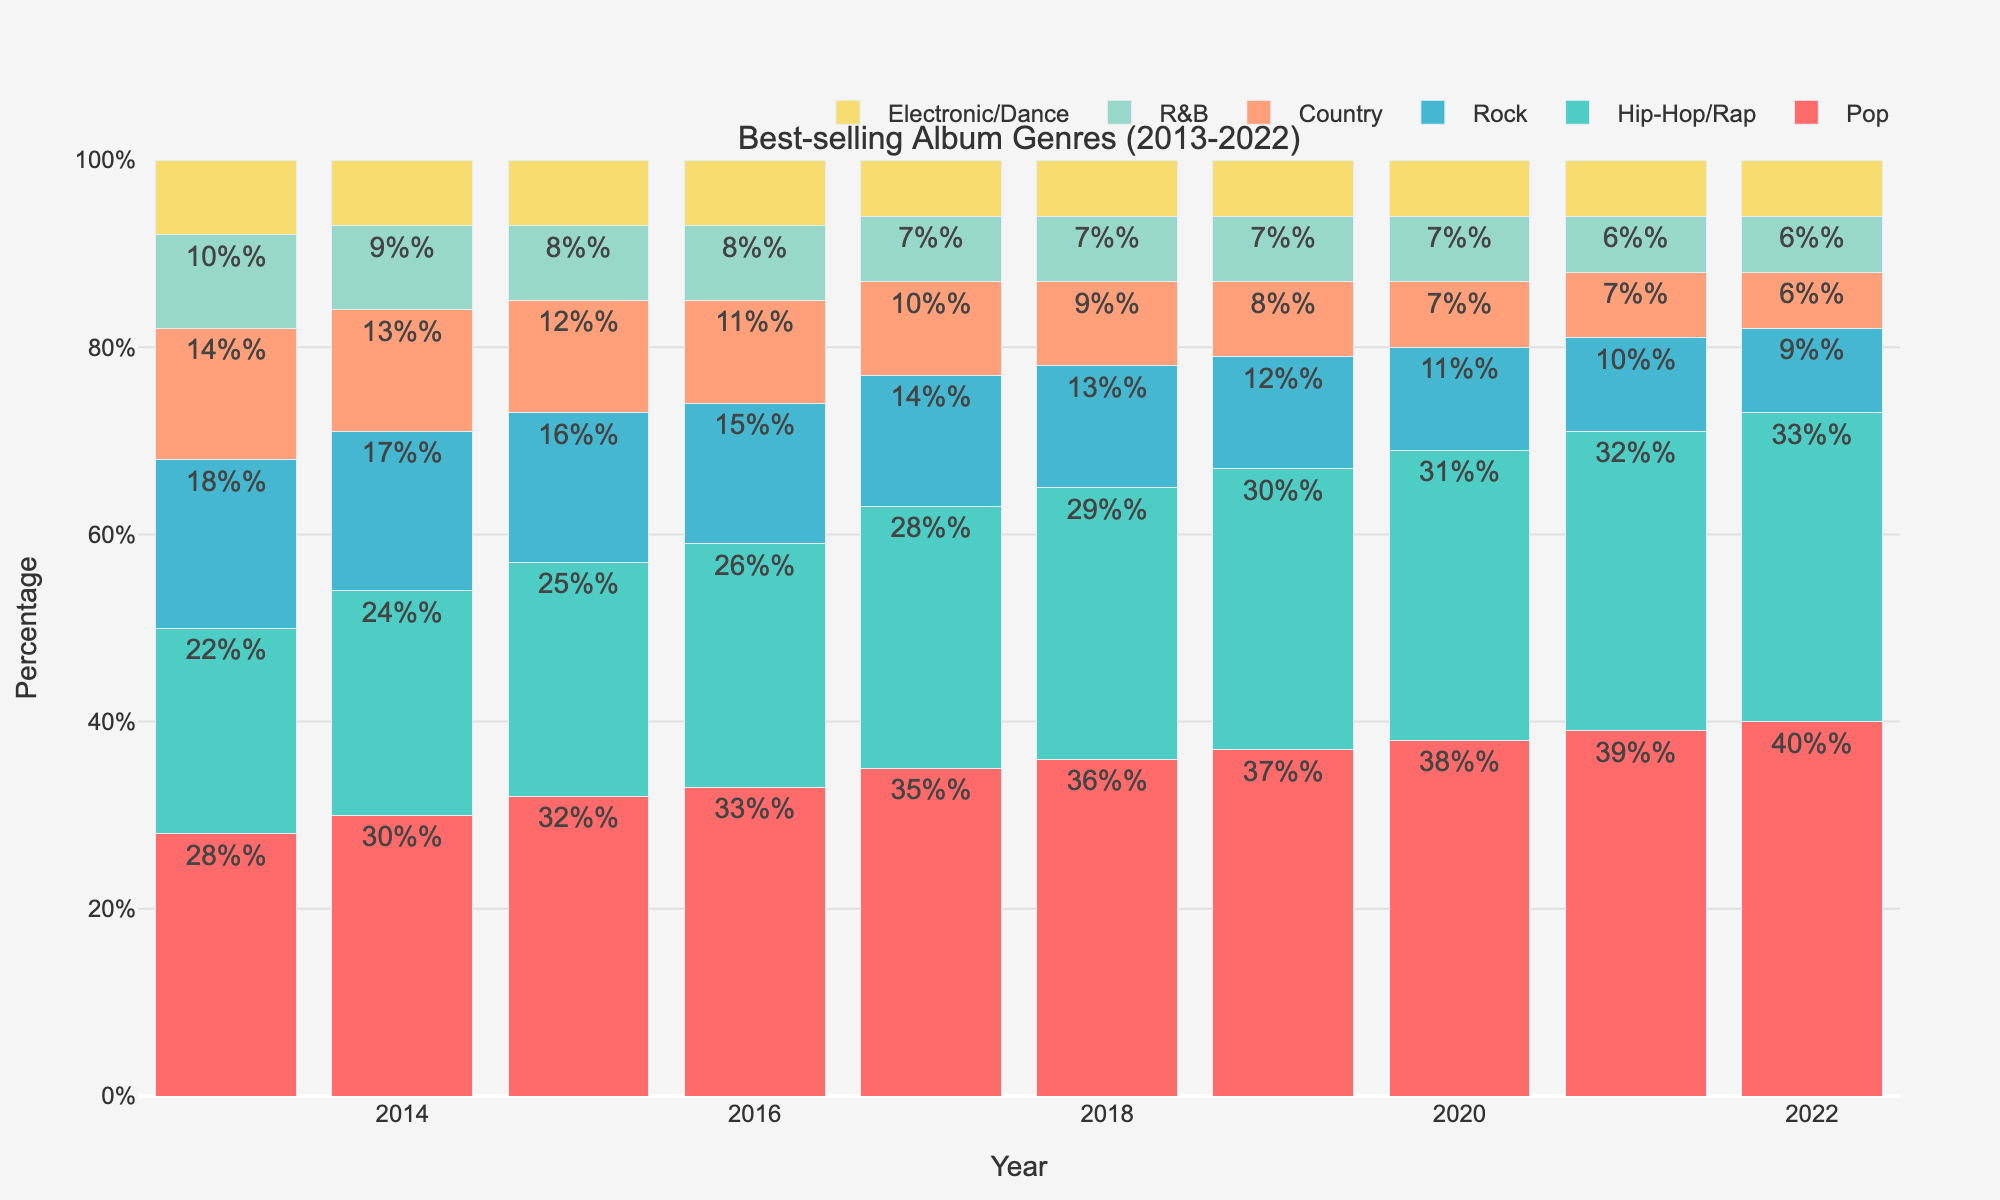Which genre experienced the highest percentage increase between 2013 and 2022? To find the highest percentage increase, we compare the values for each genre in 2013 and 2022. Pop went from 28% to 40%, Hip-Hop/Rap from 22% to 33%, Rock from 18% to 9%, Country from 14% to 6%, R&B from 10% to 6%, and Electronic/Dance remained at 6%. The highest increase is in Pop, which increased by 12%.
Answer: Pop Which genre had the lowest percentage in 2022, and what was its value? Looking at the 2022 data, the genres and their percentages are: Pop 40%, Hip-Hop/Rap 33%, Rock 9%, Country 6%, R&B 6%, and Electronic/Dance 6%. The lowest percentages are in Country, R&B, and Electronic/Dance at 6%.
Answer: Country, R&B, Electronic/Dance (6%) In which year was the percentage of Rock albums exactly double that of Electronic/Dance albums? We need to find the year where Rock's percentage is double Electronic/Dance. In 2013, Rock was at 18% and Electronic/Dance at 8%, so 18 is twice 8. This pattern does not repeat in other years.
Answer: 2013 What was the overall trend for the Hip-Hop/Rap genre from 2013 to 2022? To determine the trend, observe the yearly percentages. Hip-Hop/Rap increases every year from 22% in 2013 to 33% in 2022, showing a consistent upward trend.
Answer: Upward trend How much did the percentage of Country albums decrease from 2013 to 2022? The percentage of Country albums in 2013 was 14% and in 2022 it was 6%. The decrease is calculated as 14% - 6% = 8%.
Answer: 8% Which genre had the smallest change in percentage over the analyzed period? Comparing the percentage changes from 2013 to 2022 for all genres: Pop (12%), Hip-Hop/Rap (11%), Rock (-9%), Country (-8%), R&B (-4%), and Electronic/Dance (-2%). Electronic/Dance had the smallest change at -2%.
Answer: Electronic/Dance During which year did Pop and Hip-Hop/Rap together account for more than 60% of the best-selling album genres for the first time? Sum the percentages of Pop and Hip-Hop/Rap for each year and see when they first exceed 60%. In 2019: Pop (37%) + Hip-Hop/Rap (30%) = 67%. This is the first year the total exceeds 60%.
Answer: 2019 Which genre saw a consistent yearly increase from 2013 to 2022? Examine the yearly percentages for each genre. Pop increases from 28% to 40%, and Hip-Hop/Rap increases from 22% to 33%, showing consistent yearly increases for both genres.
Answer: Pop, Hip-Hop/Rap In what year did the percentage of R&B albums drop below 10%? Review the percentages of R&B each year. In 2014 it was 9%, so it dropped below 10% in 2014.
Answer: 2014 Which three genres had the highest combined percentage in 2016, and what was this percentage? Find the top three genres and sum their percentages for 2016. Pop 33%, Hip-Hop/Rap 26%, and Rock 15%. The combined percentage is 33% + 26% + 15% = 74%.
Answer: Pop, Hip-Hop/Rap, Rock (74%) 